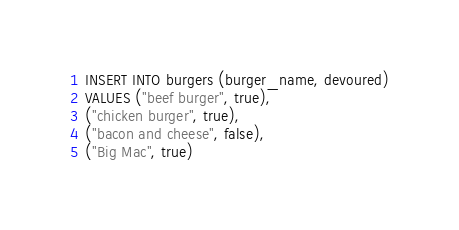<code> <loc_0><loc_0><loc_500><loc_500><_SQL_>INSERT INTO burgers (burger_name, devoured)
VALUES ("beef burger", true),
("chicken burger", true),
("bacon and cheese", false),
("Big Mac", true)</code> 